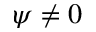<formula> <loc_0><loc_0><loc_500><loc_500>\psi \neq 0</formula> 